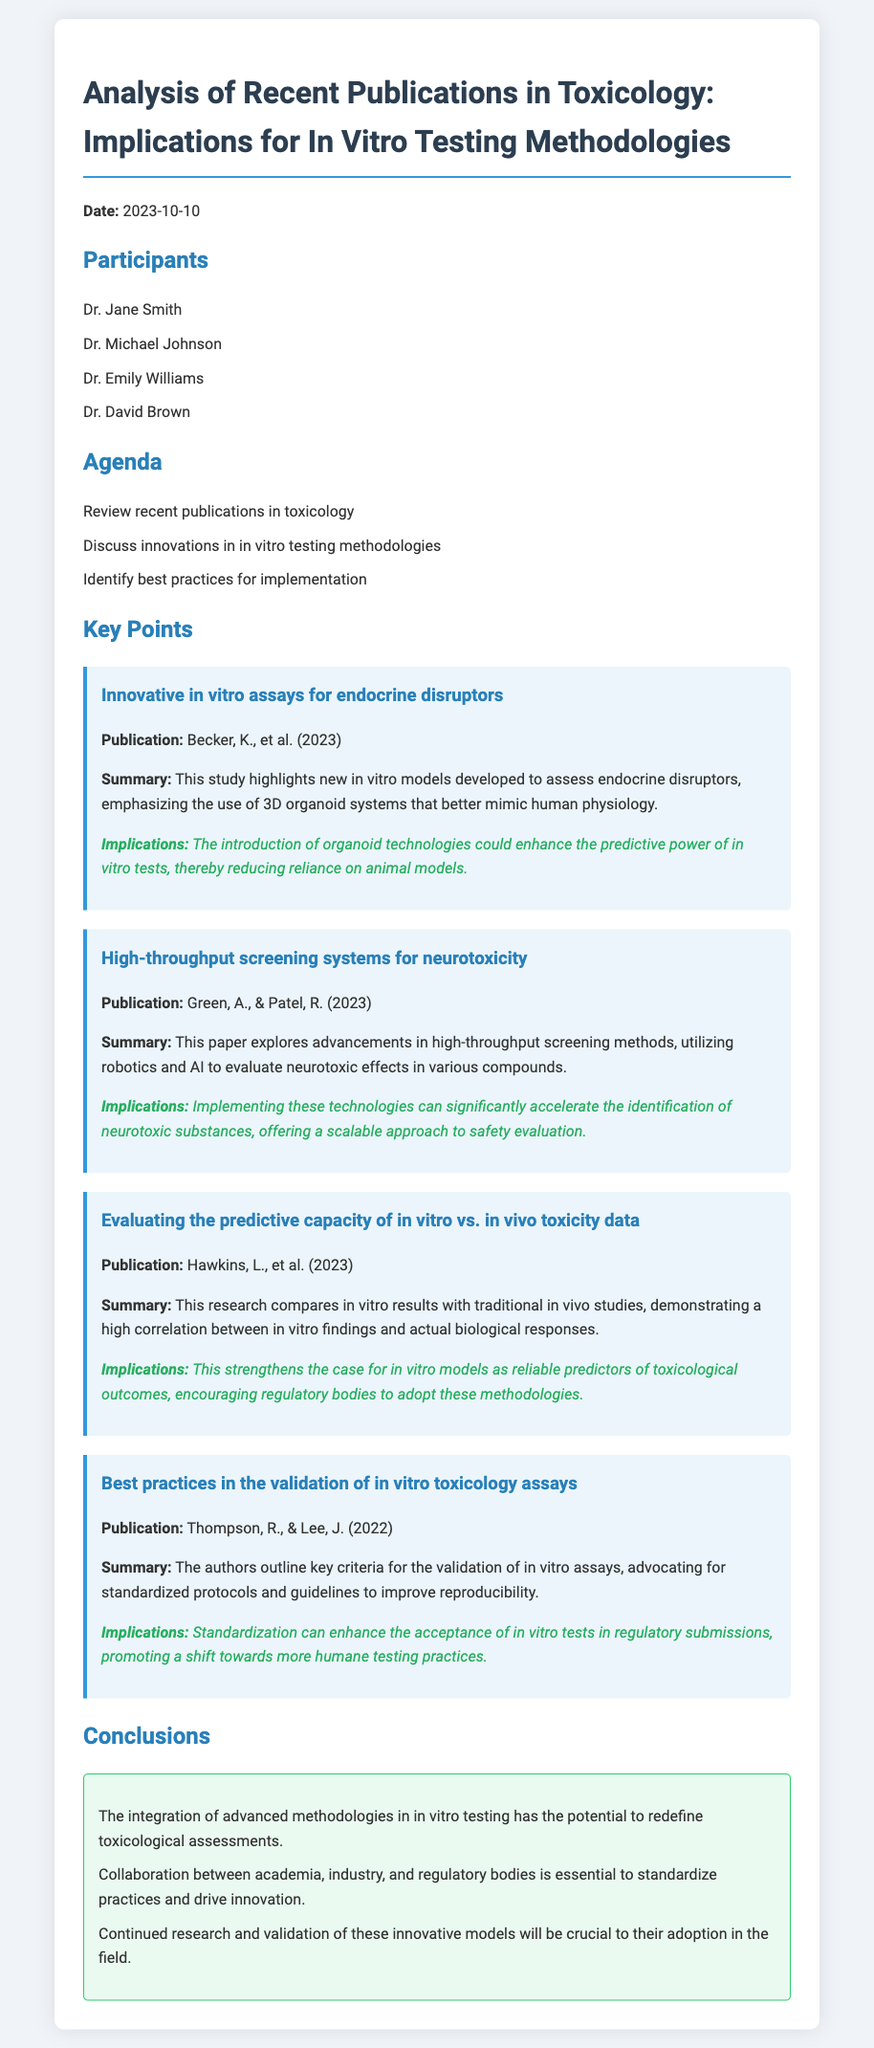What is the date of the meeting? The date of the meeting is mentioned at the beginning of the document.
Answer: 2023-10-10 Who are the participants listed in the meeting? The participants are explicitly listed under the "Participants" section in the document.
Answer: Dr. Jane Smith, Dr. Michael Johnson, Dr. Emily Williams, Dr. David Brown What are the key points discussed in the meeting? The key points are outlined within the "Key Points" section, showcasing various innovative topics.
Answer: Innovative in vitro assays for endocrine disruptors, High-throughput screening systems for neurotoxicity, Evaluating the predictive capacity of in vitro vs. in vivo toxicity data, Best practices in the validation of in vitro toxicology assays What technology was highlighted for assessing neurotoxic effects? The document points out the specific use of robotics and AI for neurotoxic evaluation under the key discussion.
Answer: Robotics and AI What is the main implication of using organoid technologies according to the meeting? The implications section provides insight into the benefits of organoid technologies for in vitro tests.
Answer: Enhance the predictive power of in vitro tests Which publication discusses best practices for validation of in vitro assays? The publication that addresses this topic is mentioned under the relevant key point.
Answer: Thompson, R., & Lee, J. (2022) How many conclusions are listed at the end of the document? The conclusions section provides a summary of findings indicated by the number of bullet points.
Answer: Three What innovation was discussed for high-throughput screening? The summary of this point refers to advancements in methods for screening.
Answer: Advancements in high-throughput screening methods 